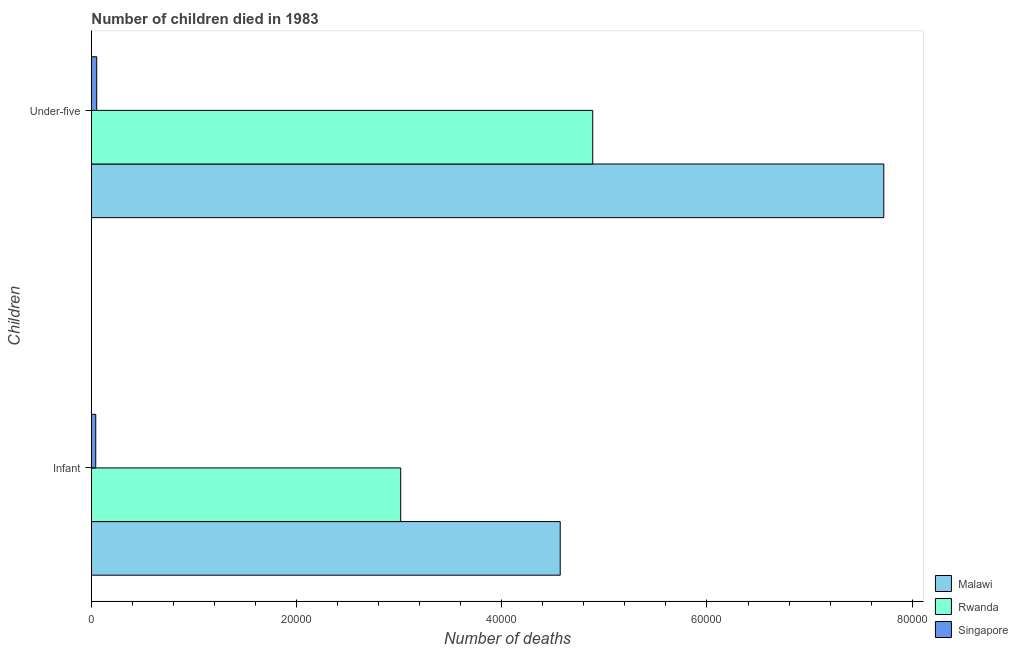How many bars are there on the 1st tick from the top?
Make the answer very short. 3. How many bars are there on the 2nd tick from the bottom?
Give a very brief answer. 3. What is the label of the 1st group of bars from the top?
Offer a terse response. Under-five. What is the number of infant deaths in Malawi?
Give a very brief answer. 4.57e+04. Across all countries, what is the maximum number of under-five deaths?
Your response must be concise. 7.72e+04. Across all countries, what is the minimum number of under-five deaths?
Your answer should be very brief. 514. In which country was the number of infant deaths maximum?
Provide a short and direct response. Malawi. In which country was the number of infant deaths minimum?
Offer a terse response. Singapore. What is the total number of infant deaths in the graph?
Provide a succinct answer. 7.63e+04. What is the difference between the number of infant deaths in Rwanda and that in Singapore?
Make the answer very short. 2.97e+04. What is the difference between the number of infant deaths in Malawi and the number of under-five deaths in Singapore?
Offer a terse response. 4.52e+04. What is the average number of infant deaths per country?
Offer a terse response. 2.54e+04. What is the difference between the number of infant deaths and number of under-five deaths in Rwanda?
Ensure brevity in your answer.  -1.87e+04. What is the ratio of the number of infant deaths in Rwanda to that in Singapore?
Provide a short and direct response. 71.44. What does the 2nd bar from the top in Infant represents?
Provide a succinct answer. Rwanda. What does the 2nd bar from the bottom in Under-five represents?
Give a very brief answer. Rwanda. How many bars are there?
Provide a succinct answer. 6. Are all the bars in the graph horizontal?
Your answer should be very brief. Yes. How many countries are there in the graph?
Keep it short and to the point. 3. Are the values on the major ticks of X-axis written in scientific E-notation?
Make the answer very short. No. Does the graph contain any zero values?
Give a very brief answer. No. Where does the legend appear in the graph?
Make the answer very short. Bottom right. How are the legend labels stacked?
Keep it short and to the point. Vertical. What is the title of the graph?
Provide a succinct answer. Number of children died in 1983. What is the label or title of the X-axis?
Offer a very short reply. Number of deaths. What is the label or title of the Y-axis?
Ensure brevity in your answer.  Children. What is the Number of deaths in Malawi in Infant?
Offer a very short reply. 4.57e+04. What is the Number of deaths of Rwanda in Infant?
Provide a short and direct response. 3.01e+04. What is the Number of deaths in Singapore in Infant?
Your answer should be compact. 422. What is the Number of deaths in Malawi in Under-five?
Provide a succinct answer. 7.72e+04. What is the Number of deaths in Rwanda in Under-five?
Your response must be concise. 4.89e+04. What is the Number of deaths in Singapore in Under-five?
Provide a short and direct response. 514. Across all Children, what is the maximum Number of deaths in Malawi?
Your response must be concise. 7.72e+04. Across all Children, what is the maximum Number of deaths in Rwanda?
Offer a terse response. 4.89e+04. Across all Children, what is the maximum Number of deaths of Singapore?
Your response must be concise. 514. Across all Children, what is the minimum Number of deaths of Malawi?
Your answer should be compact. 4.57e+04. Across all Children, what is the minimum Number of deaths of Rwanda?
Ensure brevity in your answer.  3.01e+04. Across all Children, what is the minimum Number of deaths of Singapore?
Provide a short and direct response. 422. What is the total Number of deaths of Malawi in the graph?
Ensure brevity in your answer.  1.23e+05. What is the total Number of deaths in Rwanda in the graph?
Your answer should be very brief. 7.90e+04. What is the total Number of deaths in Singapore in the graph?
Give a very brief answer. 936. What is the difference between the Number of deaths in Malawi in Infant and that in Under-five?
Make the answer very short. -3.15e+04. What is the difference between the Number of deaths of Rwanda in Infant and that in Under-five?
Keep it short and to the point. -1.87e+04. What is the difference between the Number of deaths in Singapore in Infant and that in Under-five?
Your response must be concise. -92. What is the difference between the Number of deaths in Malawi in Infant and the Number of deaths in Rwanda in Under-five?
Your response must be concise. -3169. What is the difference between the Number of deaths of Malawi in Infant and the Number of deaths of Singapore in Under-five?
Offer a terse response. 4.52e+04. What is the difference between the Number of deaths of Rwanda in Infant and the Number of deaths of Singapore in Under-five?
Make the answer very short. 2.96e+04. What is the average Number of deaths in Malawi per Children?
Keep it short and to the point. 6.15e+04. What is the average Number of deaths in Rwanda per Children?
Offer a terse response. 3.95e+04. What is the average Number of deaths in Singapore per Children?
Your answer should be compact. 468. What is the difference between the Number of deaths of Malawi and Number of deaths of Rwanda in Infant?
Give a very brief answer. 1.55e+04. What is the difference between the Number of deaths of Malawi and Number of deaths of Singapore in Infant?
Keep it short and to the point. 4.53e+04. What is the difference between the Number of deaths of Rwanda and Number of deaths of Singapore in Infant?
Your answer should be very brief. 2.97e+04. What is the difference between the Number of deaths of Malawi and Number of deaths of Rwanda in Under-five?
Ensure brevity in your answer.  2.84e+04. What is the difference between the Number of deaths in Malawi and Number of deaths in Singapore in Under-five?
Your answer should be compact. 7.67e+04. What is the difference between the Number of deaths in Rwanda and Number of deaths in Singapore in Under-five?
Ensure brevity in your answer.  4.83e+04. What is the ratio of the Number of deaths in Malawi in Infant to that in Under-five?
Keep it short and to the point. 0.59. What is the ratio of the Number of deaths in Rwanda in Infant to that in Under-five?
Offer a very short reply. 0.62. What is the ratio of the Number of deaths of Singapore in Infant to that in Under-five?
Provide a short and direct response. 0.82. What is the difference between the highest and the second highest Number of deaths in Malawi?
Your answer should be compact. 3.15e+04. What is the difference between the highest and the second highest Number of deaths of Rwanda?
Your response must be concise. 1.87e+04. What is the difference between the highest and the second highest Number of deaths in Singapore?
Ensure brevity in your answer.  92. What is the difference between the highest and the lowest Number of deaths in Malawi?
Ensure brevity in your answer.  3.15e+04. What is the difference between the highest and the lowest Number of deaths of Rwanda?
Offer a very short reply. 1.87e+04. What is the difference between the highest and the lowest Number of deaths of Singapore?
Your answer should be very brief. 92. 